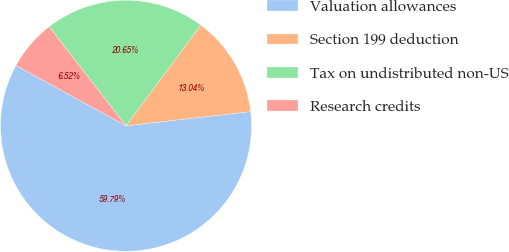Convert chart to OTSL. <chart><loc_0><loc_0><loc_500><loc_500><pie_chart><fcel>Valuation allowances<fcel>Section 199 deduction<fcel>Tax on undistributed non-US<fcel>Research credits<nl><fcel>59.78%<fcel>13.04%<fcel>20.65%<fcel>6.52%<nl></chart> 